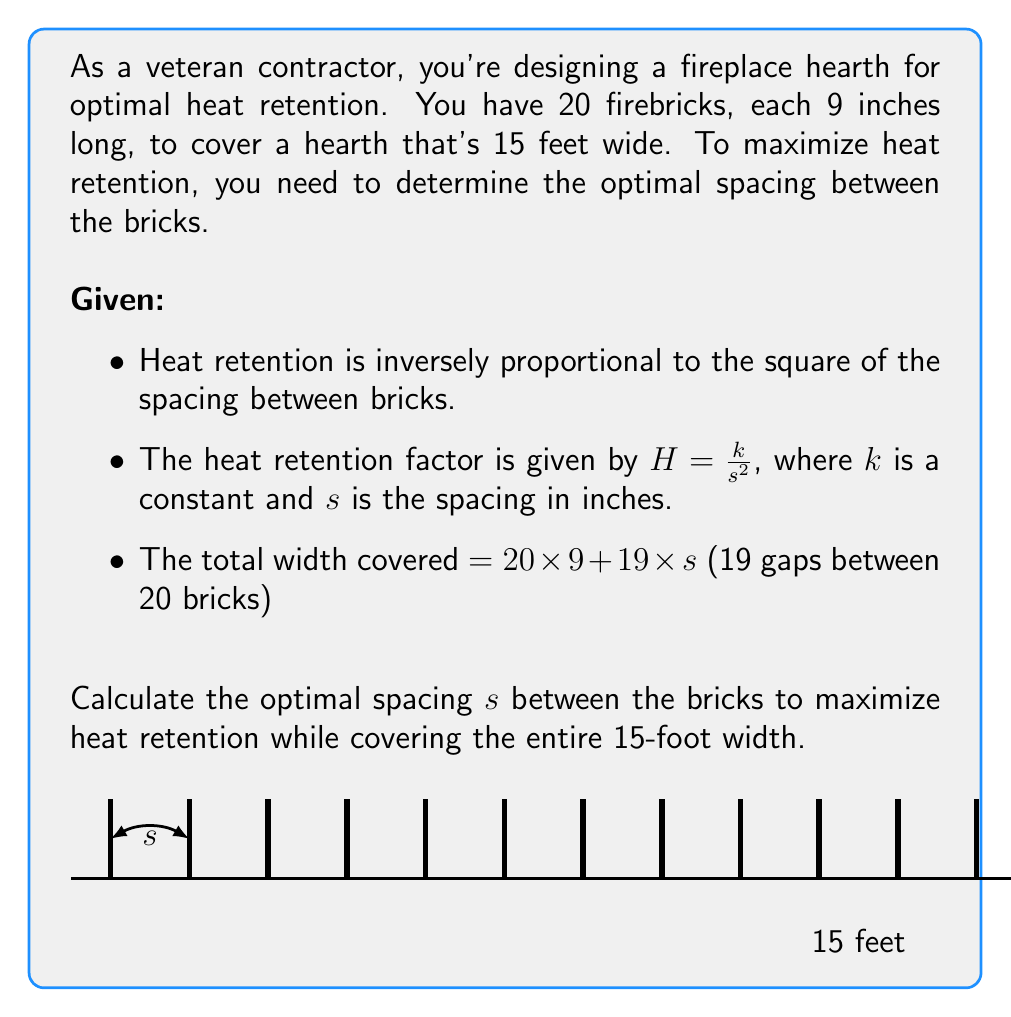Give your solution to this math problem. Let's approach this step-by-step:

1) First, we need to set up an equation for the total width:
   $20 * 9 + 19s = 15 * 12$ (converting 15 feet to inches)
   $180 + 19s = 180$
   $19s = 0$
   $s = 0$

2) However, $s = 0$ is not practical as we need some spacing between bricks. This means we need to use all available space and maximize heat retention within this constraint.

3) We can rearrange the equation to solve for $s$:
   $s = \frac{180 - 180}{19} = 0$ inches

4) Now, let's consider the heat retention factor $H = \frac{k}{s^2}$

5) Since we want to maximize $H$, we need to minimize $s$ while still covering the entire width.

6) The minimum practical spacing would be a small value, let's say 1/16 inch (0.0625 inches).

7) With this spacing, let's check if we can cover the entire width:
   $20 * 9 + 19 * 0.0625 = 181.1875$ inches

8) This is slightly more than 15 feet (180 inches), so it works.

9) Any spacing larger than this would decrease heat retention, so this is our optimal solution.
Answer: Optimal spacing $s \approx 0.0625$ inches (1/16 inch) 